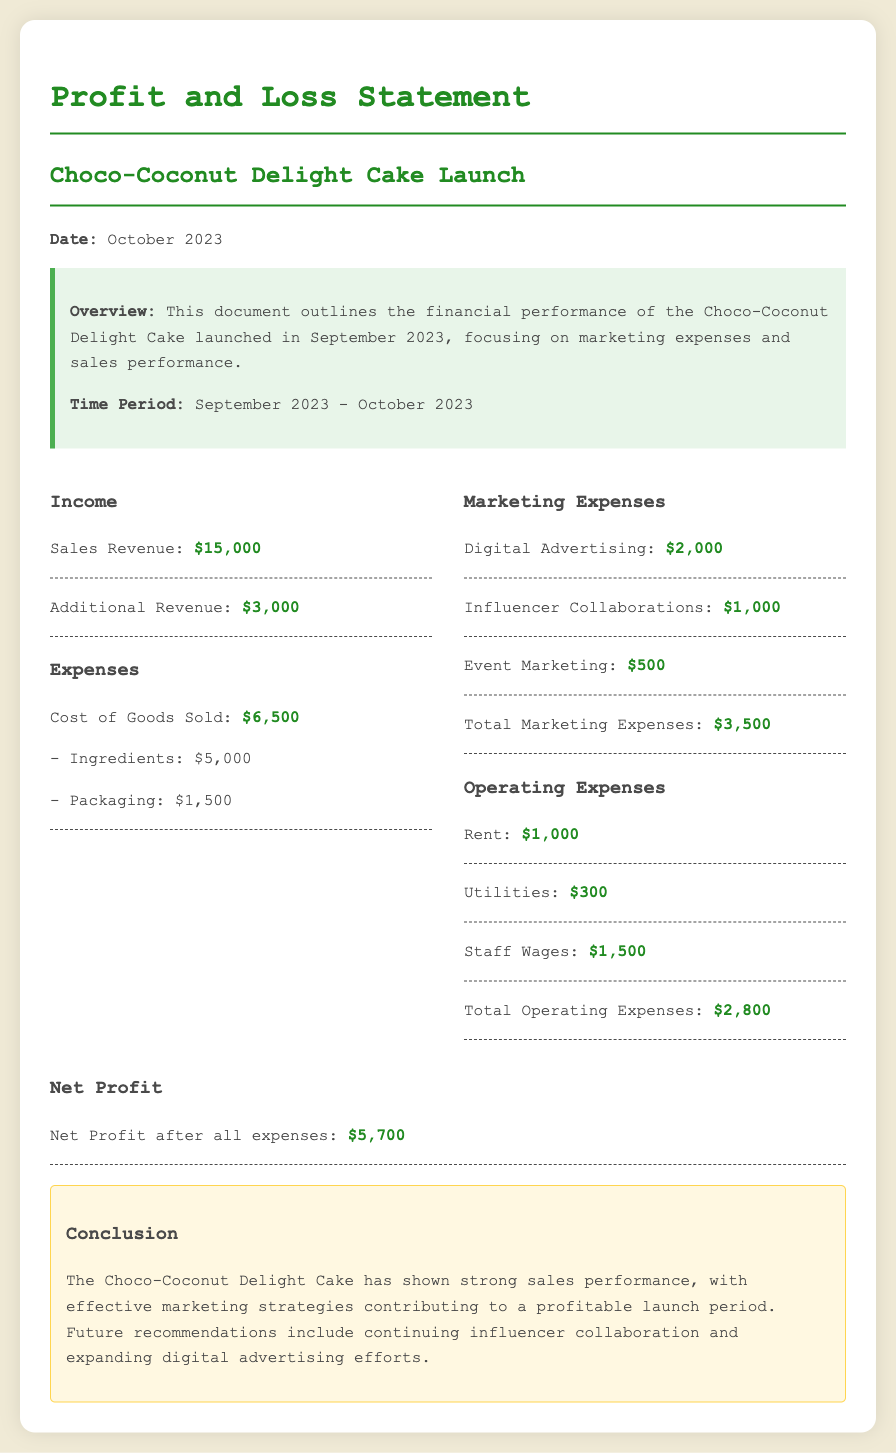What is the total sales revenue? The total sales revenue is mentioned in the document as $15,000.
Answer: $15,000 What are the total marketing expenses? The total marketing expenses are calculated as $2,000 + $1,000 + $500, which equals $3,500.
Answer: $3,500 What is the net profit after all expenses? The net profit after all expenses is stated as $5,700 in the document.
Answer: $5,700 How much was spent on digital advertising? The document specifies that $2,000 was spent on digital advertising.
Answer: $2,000 What is the time period for the financial overview? The time period for the financial overview is September 2023 - October 2023, as indicated in the introduction.
Answer: September 2023 - October 2023 How much was allocated to influencer collaborations? The allocation for influencer collaborations is mentioned as $1,000 in the marketing expenses section.
Answer: $1,000 What was the cost of goods sold? The total cost of goods sold is detailed as $6,500 in the expenses section.
Answer: $6,500 What recommendation is made for future marketing efforts? The document recommends continuing influencer collaboration and expanding digital advertising efforts.
Answer: Continuing influencer collaboration and expanding digital advertising efforts What is the total for operating expenses? The total for operating expenses is listed as $2,800 in the financial data section.
Answer: $2,800 